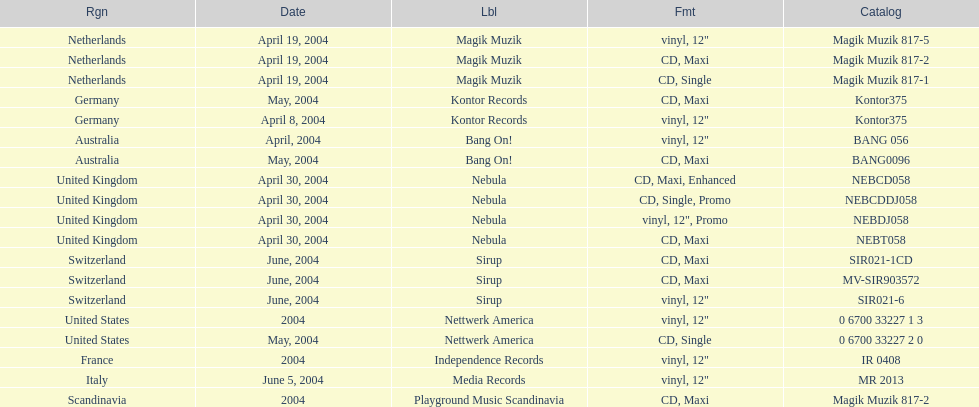What is the total number of catalogs published? 19. Could you parse the entire table? {'header': ['Rgn', 'Date', 'Lbl', 'Fmt', 'Catalog'], 'rows': [['Netherlands', 'April 19, 2004', 'Magik Muzik', 'vinyl, 12"', 'Magik Muzik 817-5'], ['Netherlands', 'April 19, 2004', 'Magik Muzik', 'CD, Maxi', 'Magik Muzik 817-2'], ['Netherlands', 'April 19, 2004', 'Magik Muzik', 'CD, Single', 'Magik Muzik 817-1'], ['Germany', 'May, 2004', 'Kontor Records', 'CD, Maxi', 'Kontor375'], ['Germany', 'April 8, 2004', 'Kontor Records', 'vinyl, 12"', 'Kontor375'], ['Australia', 'April, 2004', 'Bang On!', 'vinyl, 12"', 'BANG 056'], ['Australia', 'May, 2004', 'Bang On!', 'CD, Maxi', 'BANG0096'], ['United Kingdom', 'April 30, 2004', 'Nebula', 'CD, Maxi, Enhanced', 'NEBCD058'], ['United Kingdom', 'April 30, 2004', 'Nebula', 'CD, Single, Promo', 'NEBCDDJ058'], ['United Kingdom', 'April 30, 2004', 'Nebula', 'vinyl, 12", Promo', 'NEBDJ058'], ['United Kingdom', 'April 30, 2004', 'Nebula', 'CD, Maxi', 'NEBT058'], ['Switzerland', 'June, 2004', 'Sirup', 'CD, Maxi', 'SIR021-1CD'], ['Switzerland', 'June, 2004', 'Sirup', 'CD, Maxi', 'MV-SIR903572'], ['Switzerland', 'June, 2004', 'Sirup', 'vinyl, 12"', 'SIR021-6'], ['United States', '2004', 'Nettwerk America', 'vinyl, 12"', '0 6700 33227 1 3'], ['United States', 'May, 2004', 'Nettwerk America', 'CD, Single', '0 6700 33227 2 0'], ['France', '2004', 'Independence Records', 'vinyl, 12"', 'IR 0408'], ['Italy', 'June 5, 2004', 'Media Records', 'vinyl, 12"', 'MR 2013'], ['Scandinavia', '2004', 'Playground Music Scandinavia', 'CD, Maxi', 'Magik Muzik 817-2']]} 